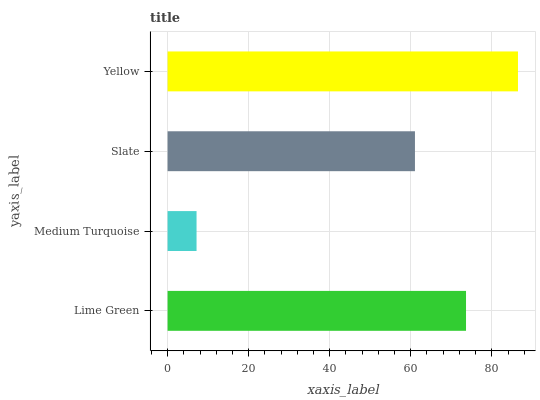Is Medium Turquoise the minimum?
Answer yes or no. Yes. Is Yellow the maximum?
Answer yes or no. Yes. Is Slate the minimum?
Answer yes or no. No. Is Slate the maximum?
Answer yes or no. No. Is Slate greater than Medium Turquoise?
Answer yes or no. Yes. Is Medium Turquoise less than Slate?
Answer yes or no. Yes. Is Medium Turquoise greater than Slate?
Answer yes or no. No. Is Slate less than Medium Turquoise?
Answer yes or no. No. Is Lime Green the high median?
Answer yes or no. Yes. Is Slate the low median?
Answer yes or no. Yes. Is Medium Turquoise the high median?
Answer yes or no. No. Is Lime Green the low median?
Answer yes or no. No. 